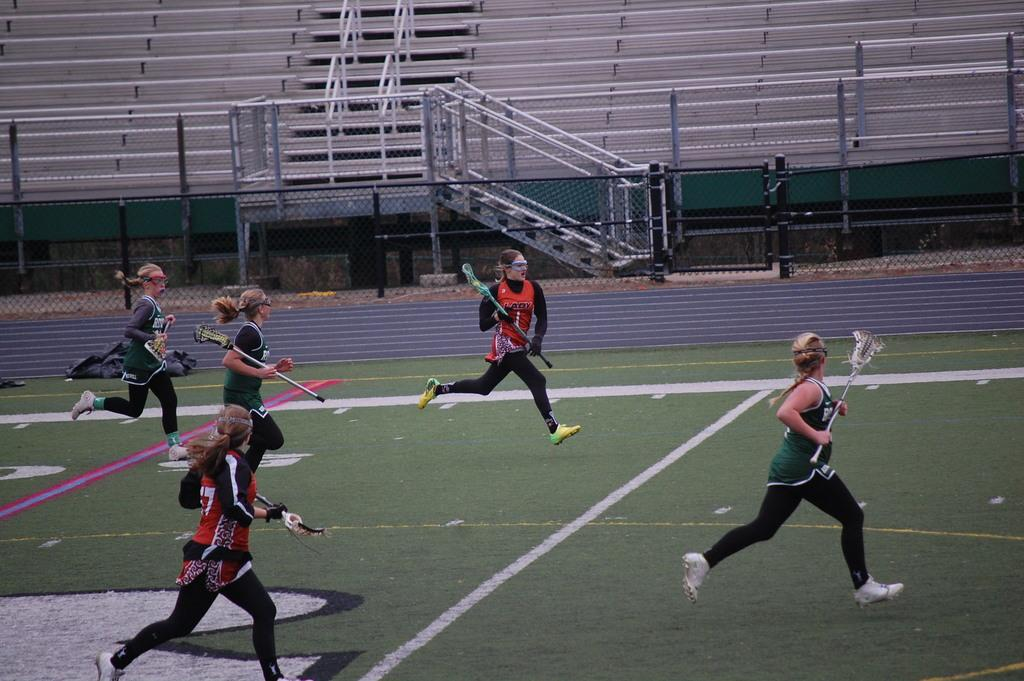What are the people in the image doing? The people in the image are running. What are the people holding while running? The people are holding sticks. What can be seen in the background of the image? There is a metal fence, railing, and stairs in the background of the image. What type of food is being served from the truck in the image? There is no truck present in the image, so no food is being served. Who needs to approve the actions of the people running in the image? The image does not require any approval, as it is a still photograph. 